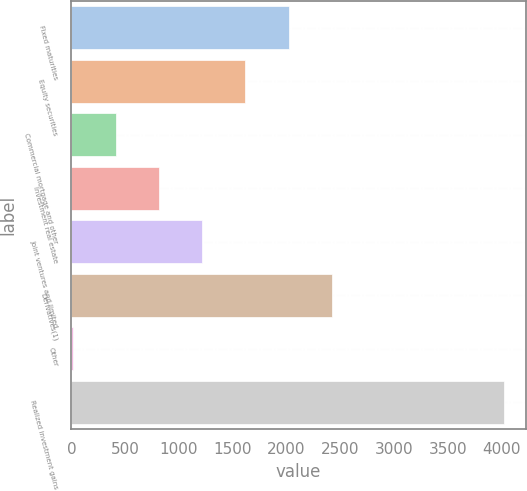<chart> <loc_0><loc_0><loc_500><loc_500><bar_chart><fcel>Fixed maturities<fcel>Equity securities<fcel>Commercial mortgage and other<fcel>Investment real estate<fcel>Joint ventures and limited<fcel>Derivatives(1)<fcel>Other<fcel>Realized investment gains<nl><fcel>2020<fcel>1619<fcel>416<fcel>817<fcel>1218<fcel>2421<fcel>15<fcel>4025<nl></chart> 